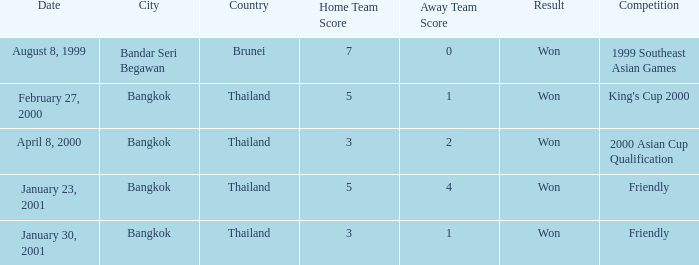When was the match with a 7-0 score held? August 8, 1999. 